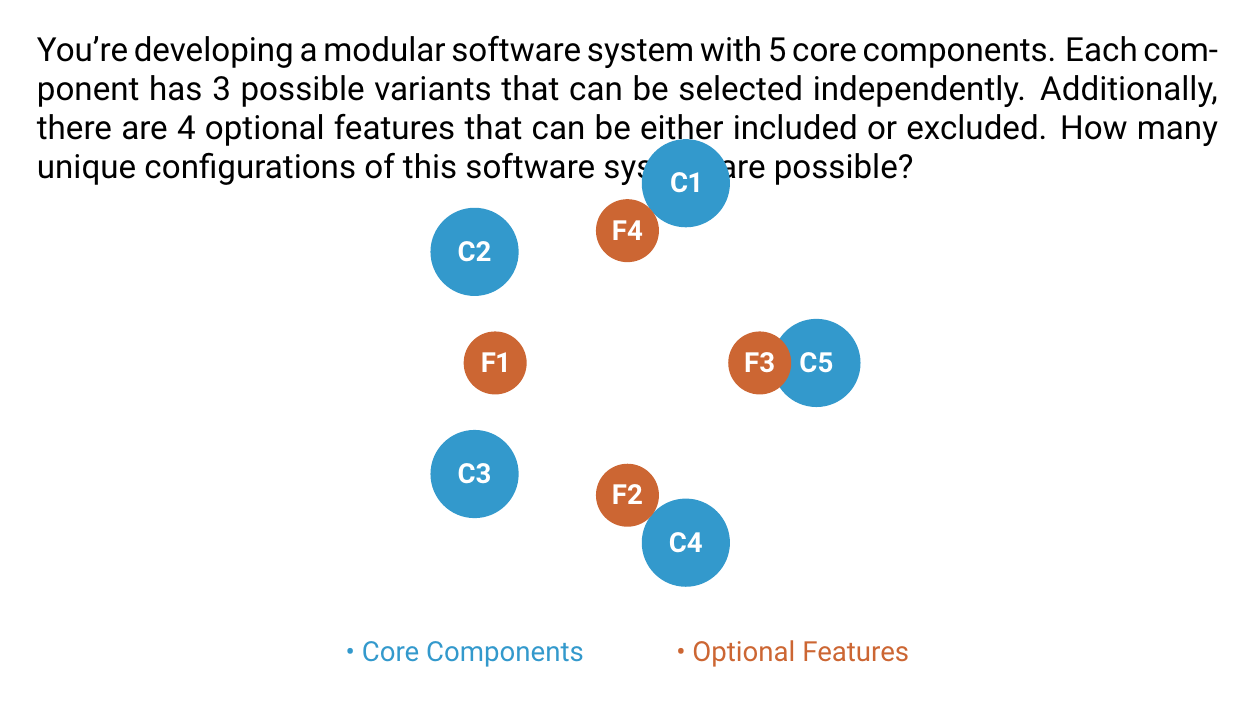Help me with this question. Let's break this down step-by-step:

1) First, let's consider the core components:
   - There are 5 core components
   - Each component has 3 possible variants
   - These can be selected independently
   
   The number of possibilities for core components is thus:
   $$ 3^5 = 243 $$

2) Now, let's consider the optional features:
   - There are 4 optional features
   - Each feature can be either included (1) or excluded (0)
   - These can be selected independently
   
   The number of possibilities for optional features is:
   $$ 2^4 = 16 $$

3) To get the total number of unique configurations, we need to multiply these together:
   $$ \text{Total Configurations} = \text{Core Configurations} \times \text{Optional Configurations} $$
   $$ \text{Total Configurations} = 3^5 \times 2^4 = 243 \times 16 = 3,888 $$

This multiplication works because for each possible configuration of core components (243), we can have any of the possible configurations of optional features (16), resulting in 243 * 16 unique overall configurations.
Answer: $3^5 \times 2^4 = 3,888$ 